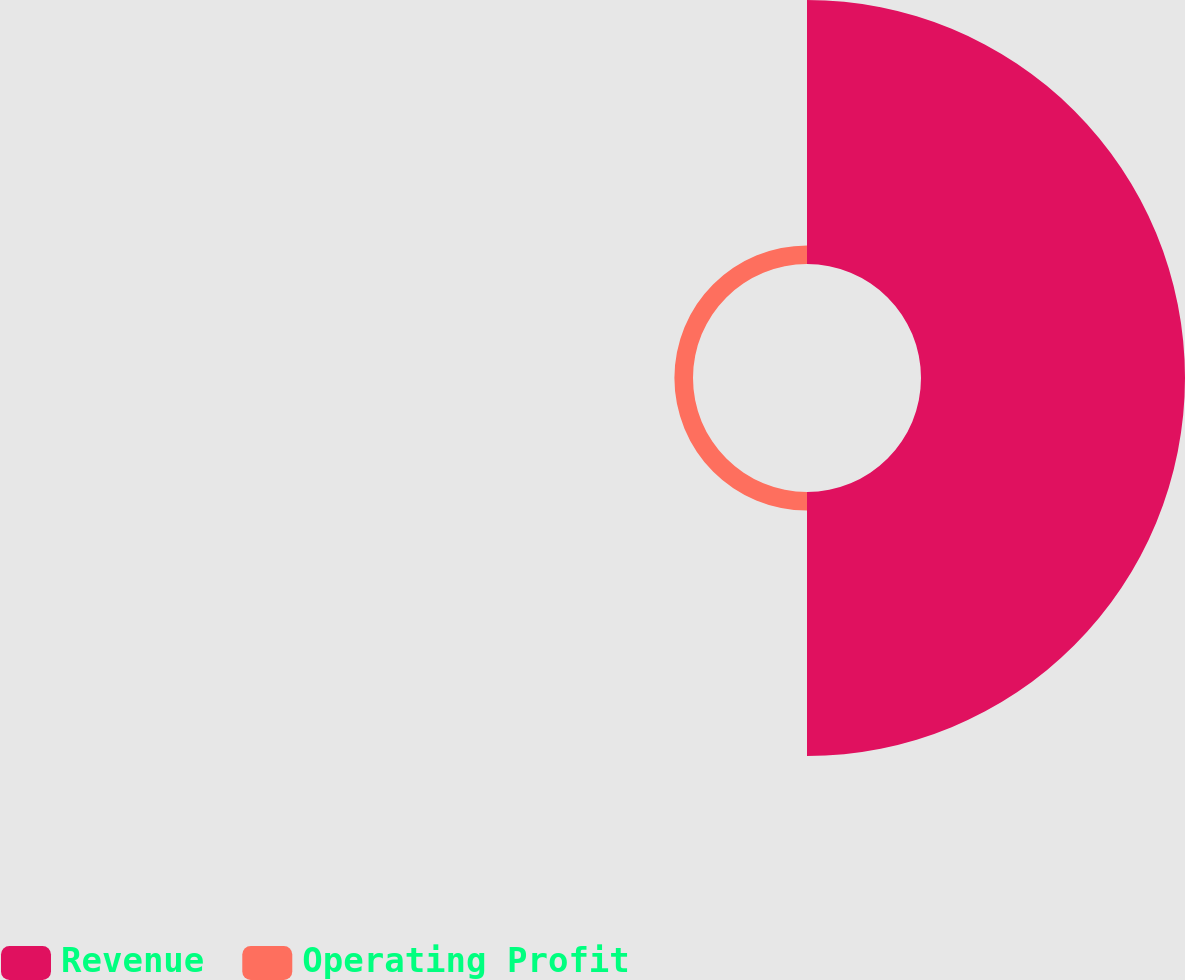<chart> <loc_0><loc_0><loc_500><loc_500><pie_chart><fcel>Revenue<fcel>Operating Profit<nl><fcel>93.42%<fcel>6.58%<nl></chart> 